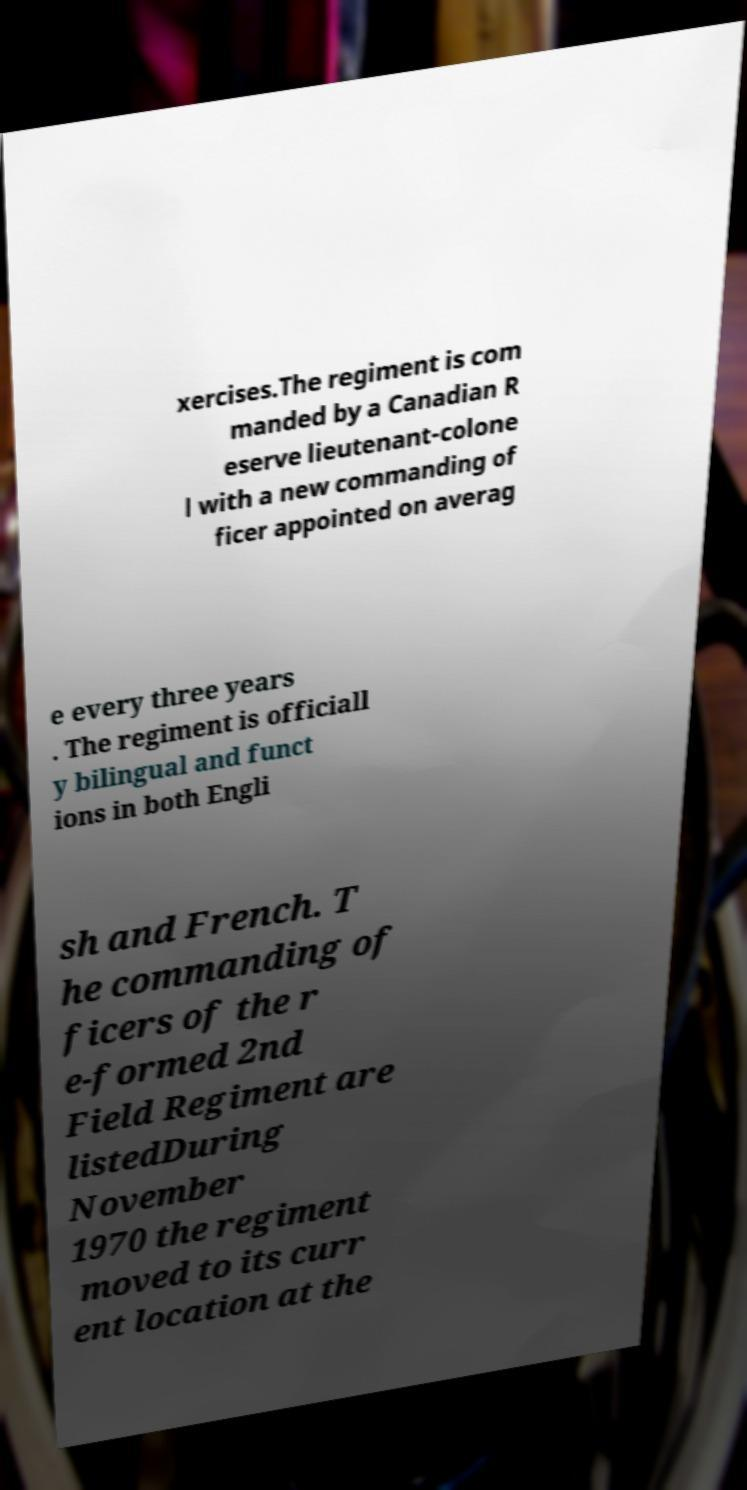I need the written content from this picture converted into text. Can you do that? xercises.The regiment is com manded by a Canadian R eserve lieutenant-colone l with a new commanding of ficer appointed on averag e every three years . The regiment is officiall y bilingual and funct ions in both Engli sh and French. T he commanding of ficers of the r e-formed 2nd Field Regiment are listedDuring November 1970 the regiment moved to its curr ent location at the 